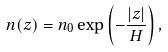Convert formula to latex. <formula><loc_0><loc_0><loc_500><loc_500>n ( z ) = n _ { 0 } \exp \left ( - \frac { | z | } { H } \right ) ,</formula> 